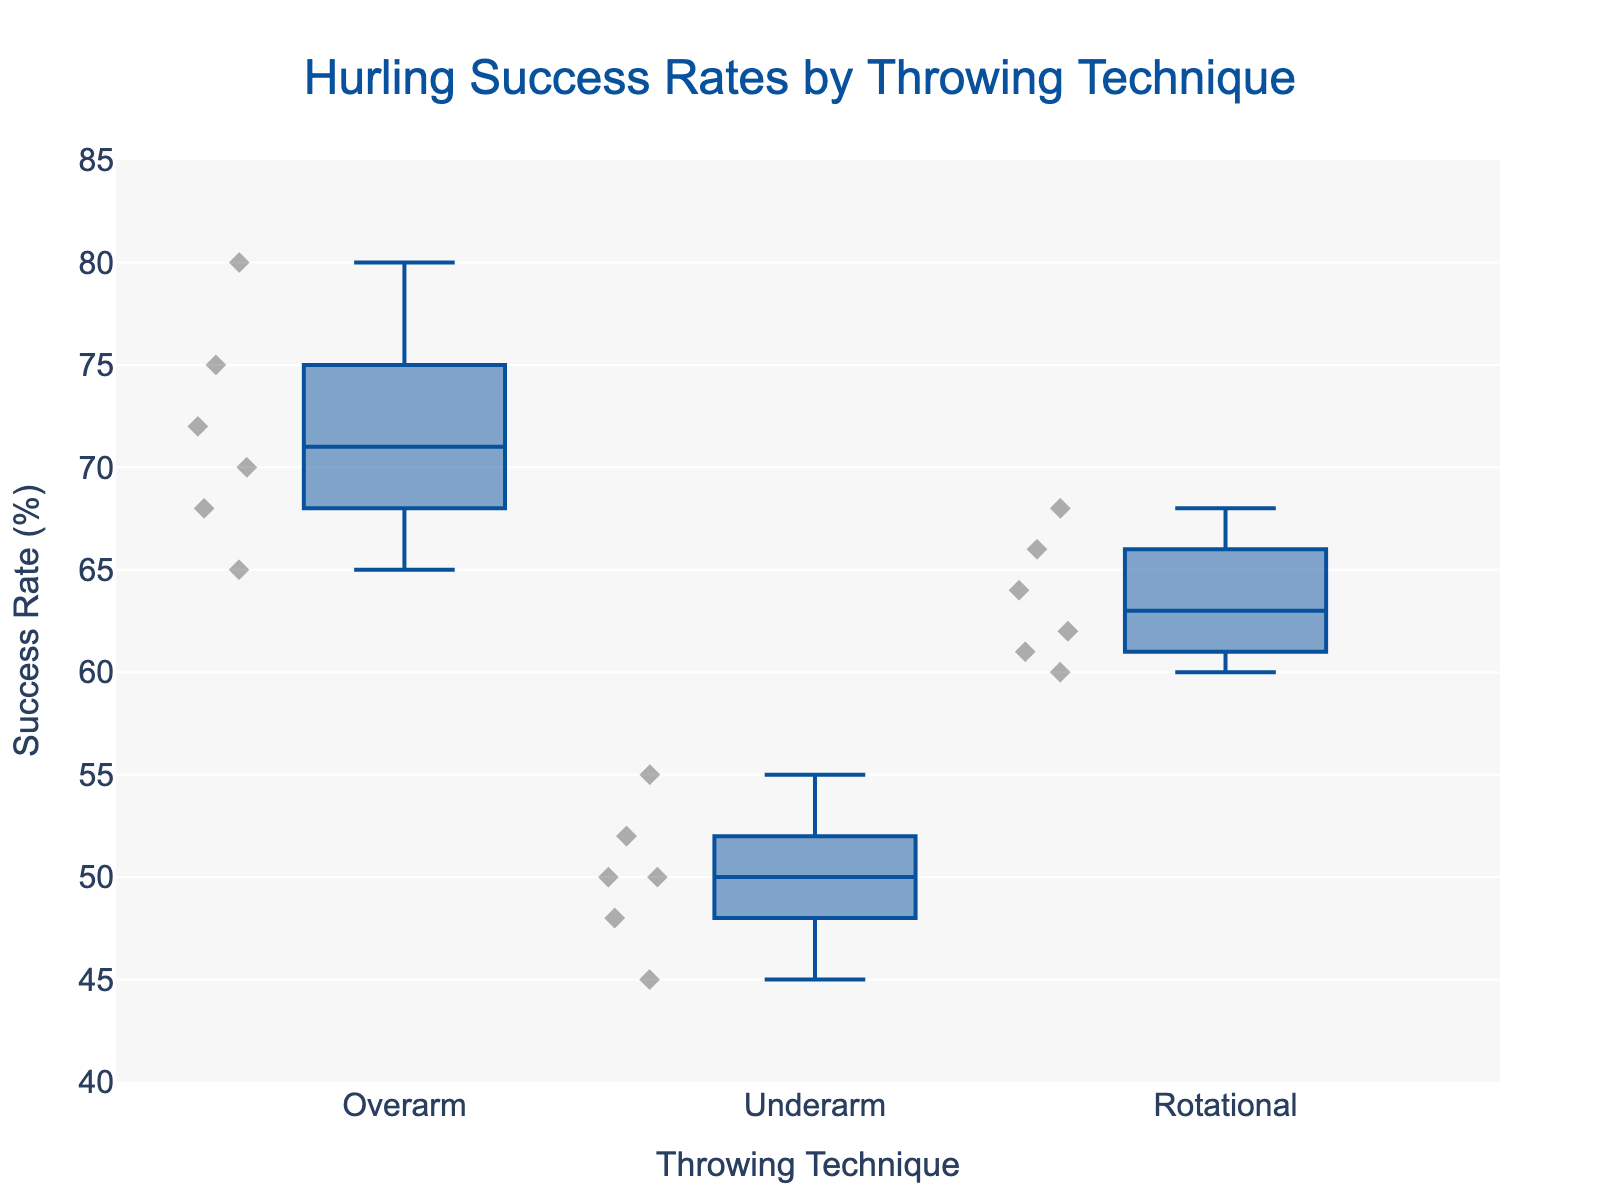What is the title of the plot? The title of the plot is located at the top center and gives an overall summary of the figure's content. It’s usually in larger font and more prominent.
Answer: Hurling Success Rates by Throwing Technique Which throwing technique has the highest median success rate? The median can be identified by the line inside the central box of each technique. Comparing these lines across techniques, we see which is the highest.
Answer: Overarm What is the range of success rates for the Underarm throwing technique? The range is obtained by subtracting the minimum value from the maximum value within the whiskers of the Underarm box plot.
Answer: 45-55 How does the average success rate of the Overarm technique compare with the Rotational technique? Calculate the average of each technique by adding up all the success rates and dividing by the number of points and then compare.
Answer: Overarm has a higher average success rate Which technique shows the most variation in success rates? Variation is indicated by the length of the box and the whiskers. The technique with the longest box and whiskers has the most variation.
Answer: Underarm Are there any outliers for the Rotational technique? Outliers are typically depicted as individual points outside the whiskers of the box plot. Checking if any points fall significantly outside the main range of the Rotational box plot.
Answer: No Between the Underarm and Rotational techniques, which has a higher lowest success rate? Examine the bottom whisker of each technique’s box plot to find the lower extreme and compare them.
Answer: Rotational What is the interquartile range (IQR) for the Overarm technique? The IQR is the difference between the 75th percentile (top of the box) and the 25th percentile (bottom of the box) of the box plot for the Overarm technique.
Answer: 8 How many data points are there for the Underarm technique? Each point represents a data point and are scattered around the box plot. Counting them gives the total number.
Answer: 6 